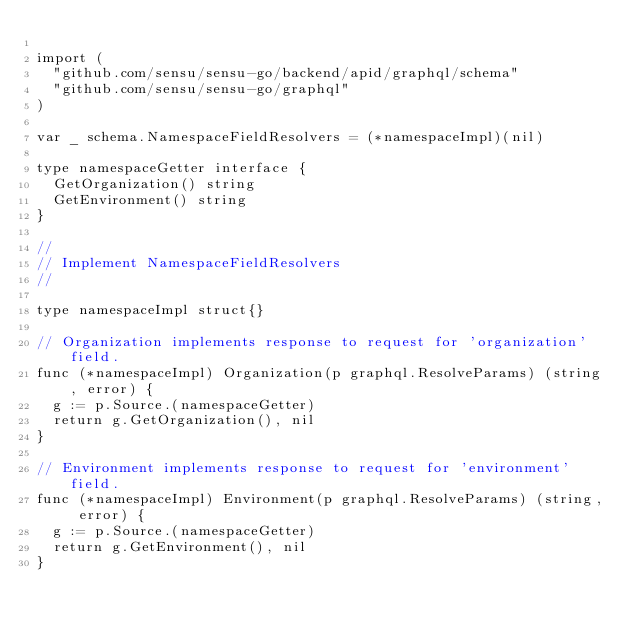<code> <loc_0><loc_0><loc_500><loc_500><_Go_>
import (
	"github.com/sensu/sensu-go/backend/apid/graphql/schema"
	"github.com/sensu/sensu-go/graphql"
)

var _ schema.NamespaceFieldResolvers = (*namespaceImpl)(nil)

type namespaceGetter interface {
	GetOrganization() string
	GetEnvironment() string
}

//
// Implement NamespaceFieldResolvers
//

type namespaceImpl struct{}

// Organization implements response to request for 'organization' field.
func (*namespaceImpl) Organization(p graphql.ResolveParams) (string, error) {
	g := p.Source.(namespaceGetter)
	return g.GetOrganization(), nil
}

// Environment implements response to request for 'environment' field.
func (*namespaceImpl) Environment(p graphql.ResolveParams) (string, error) {
	g := p.Source.(namespaceGetter)
	return g.GetEnvironment(), nil
}
</code> 